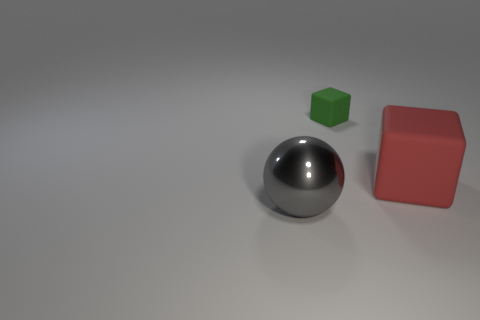Add 1 large things. How many objects exist? 4 Subtract all balls. How many objects are left? 2 Add 1 big green cubes. How many big green cubes exist? 1 Subtract 0 brown cylinders. How many objects are left? 3 Subtract all tiny things. Subtract all tiny green rubber things. How many objects are left? 1 Add 1 large matte objects. How many large matte objects are left? 2 